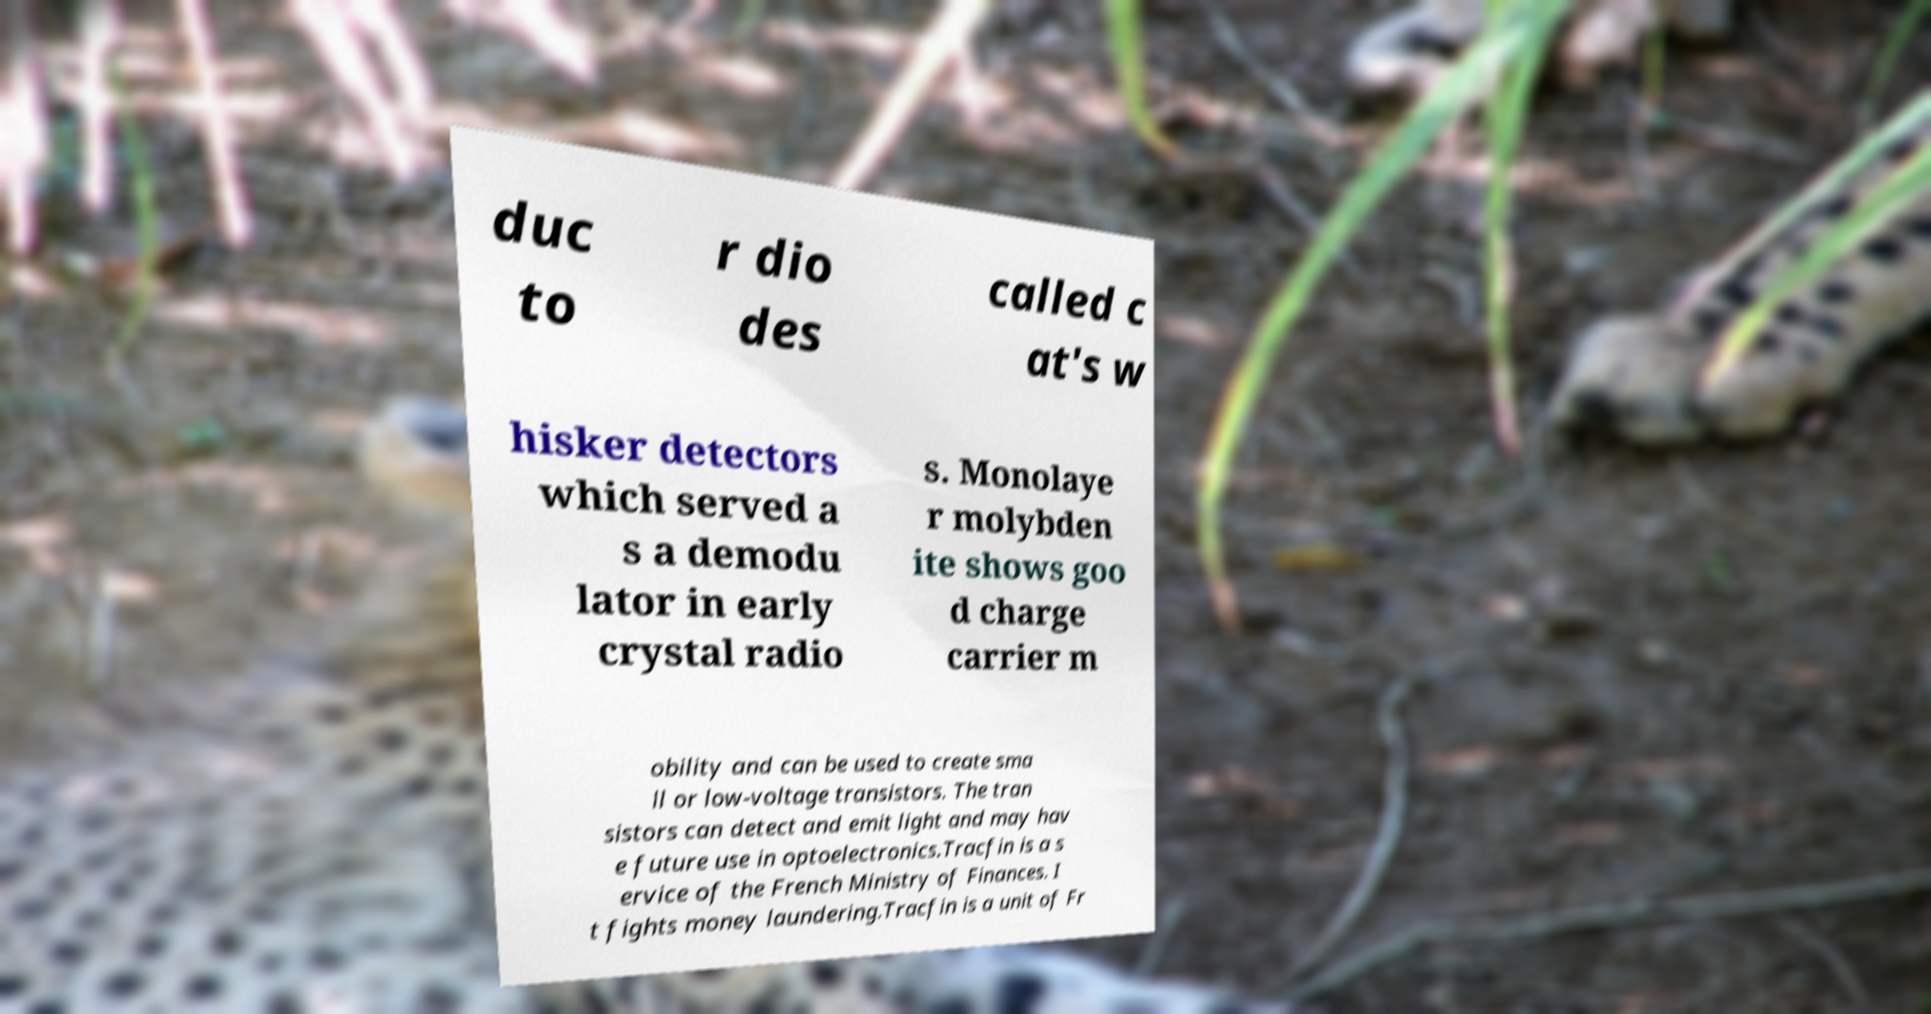There's text embedded in this image that I need extracted. Can you transcribe it verbatim? duc to r dio des called c at's w hisker detectors which served a s a demodu lator in early crystal radio s. Monolaye r molybden ite shows goo d charge carrier m obility and can be used to create sma ll or low-voltage transistors. The tran sistors can detect and emit light and may hav e future use in optoelectronics.Tracfin is a s ervice of the French Ministry of Finances. I t fights money laundering.Tracfin is a unit of Fr 